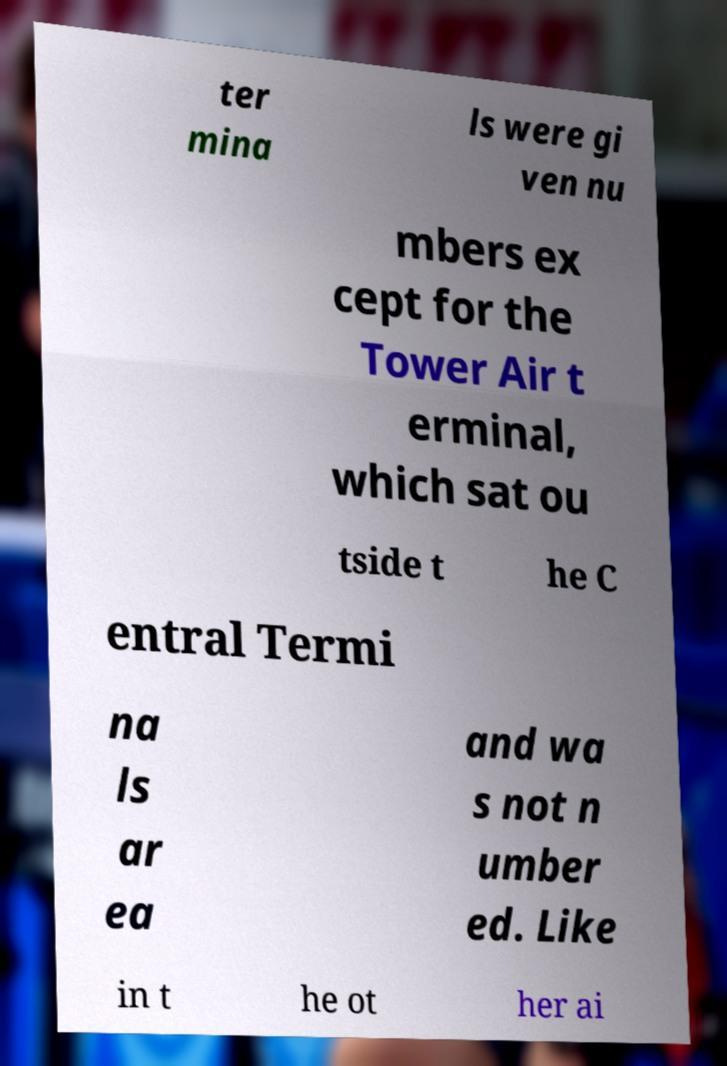Could you extract and type out the text from this image? ter mina ls were gi ven nu mbers ex cept for the Tower Air t erminal, which sat ou tside t he C entral Termi na ls ar ea and wa s not n umber ed. Like in t he ot her ai 